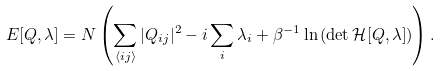Convert formula to latex. <formula><loc_0><loc_0><loc_500><loc_500>E [ Q , \lambda ] = N \left ( \sum _ { \langle i j \rangle } | Q _ { i j } | ^ { 2 } - i \sum _ { i } \lambda _ { i } + \beta ^ { - 1 } \ln { ( \det { { \mathcal { H } } [ Q , \lambda ] } ) } \right ) .</formula> 